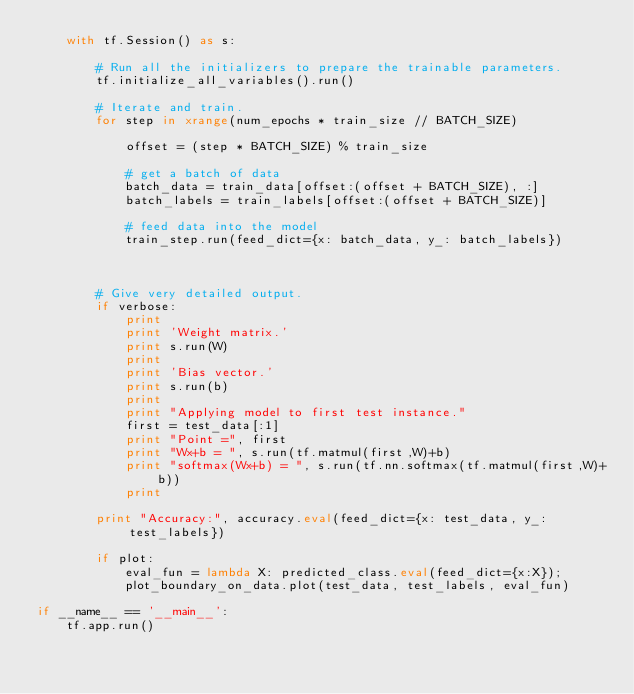<code> <loc_0><loc_0><loc_500><loc_500><_Python_>    with tf.Session() as s:

        # Run all the initializers to prepare the trainable parameters.
        tf.initialize_all_variables().run()
        
        # Iterate and train.
        for step in xrange(num_epochs * train_size // BATCH_SIZE)
    
            offset = (step * BATCH_SIZE) % train_size

            # get a batch of data
            batch_data = train_data[offset:(offset + BATCH_SIZE), :]
            batch_labels = train_labels[offset:(offset + BATCH_SIZE)]

            # feed data into the model
            train_step.run(feed_dict={x: batch_data, y_: batch_labels})
            


        # Give very detailed output.
        if verbose:
            print
            print 'Weight matrix.'
            print s.run(W)
            print
            print 'Bias vector.'
            print s.run(b)
            print
            print "Applying model to first test instance."
            first = test_data[:1]
            print "Point =", first
            print "Wx+b = ", s.run(tf.matmul(first,W)+b)
            print "softmax(Wx+b) = ", s.run(tf.nn.softmax(tf.matmul(first,W)+b))
            print
            
        print "Accuracy:", accuracy.eval(feed_dict={x: test_data, y_: test_labels})

        if plot:
            eval_fun = lambda X: predicted_class.eval(feed_dict={x:X}); 
            plot_boundary_on_data.plot(test_data, test_labels, eval_fun)
    
if __name__ == '__main__':
    tf.app.run()
</code> 